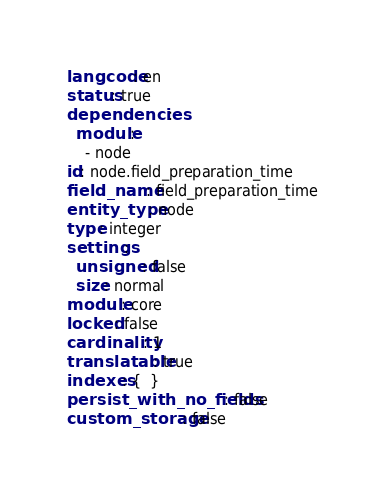Convert code to text. <code><loc_0><loc_0><loc_500><loc_500><_YAML_>langcode: en
status: true
dependencies:
  module:
    - node
id: node.field_preparation_time
field_name: field_preparation_time
entity_type: node
type: integer
settings:
  unsigned: false
  size: normal
module: core
locked: false
cardinality: 1
translatable: true
indexes: {  }
persist_with_no_fields: false
custom_storage: false
</code> 